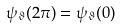Convert formula to latex. <formula><loc_0><loc_0><loc_500><loc_500>\psi _ { \vartheta } ( 2 \pi ) = \psi _ { \vartheta } ( 0 )</formula> 